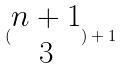<formula> <loc_0><loc_0><loc_500><loc_500>( \begin{matrix} n + 1 \\ 3 \end{matrix} ) + 1</formula> 